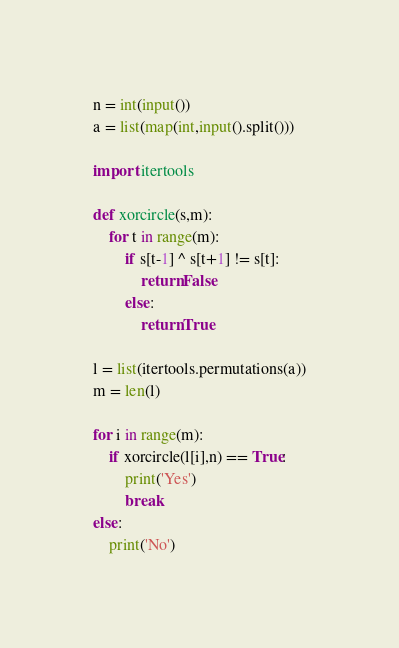<code> <loc_0><loc_0><loc_500><loc_500><_Python_>n = int(input())
a = list(map(int,input().split()))

import itertools

def xorcircle(s,m):
    for t in range(m):
        if s[t-1] ^ s[t+1] != s[t]:
            return False
        else:
            return True
        
l = list(itertools.permutations(a))
m = len(l)

for i in range(m):
    if xorcircle(l[i],n) == True:
        print('Yes')
        break
else:
    print('No')</code> 